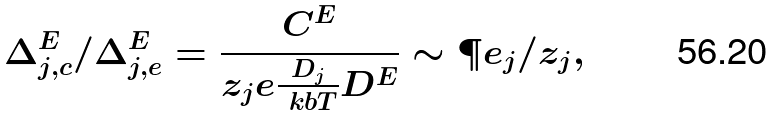Convert formula to latex. <formula><loc_0><loc_0><loc_500><loc_500>\Delta _ { j , c } ^ { E } / \Delta _ { j , e } ^ { E } = \frac { C ^ { E } } { z _ { j } e \frac { D _ { j } } { \ k b T } D ^ { E } } \sim \P e _ { j } / z _ { j } ,</formula> 